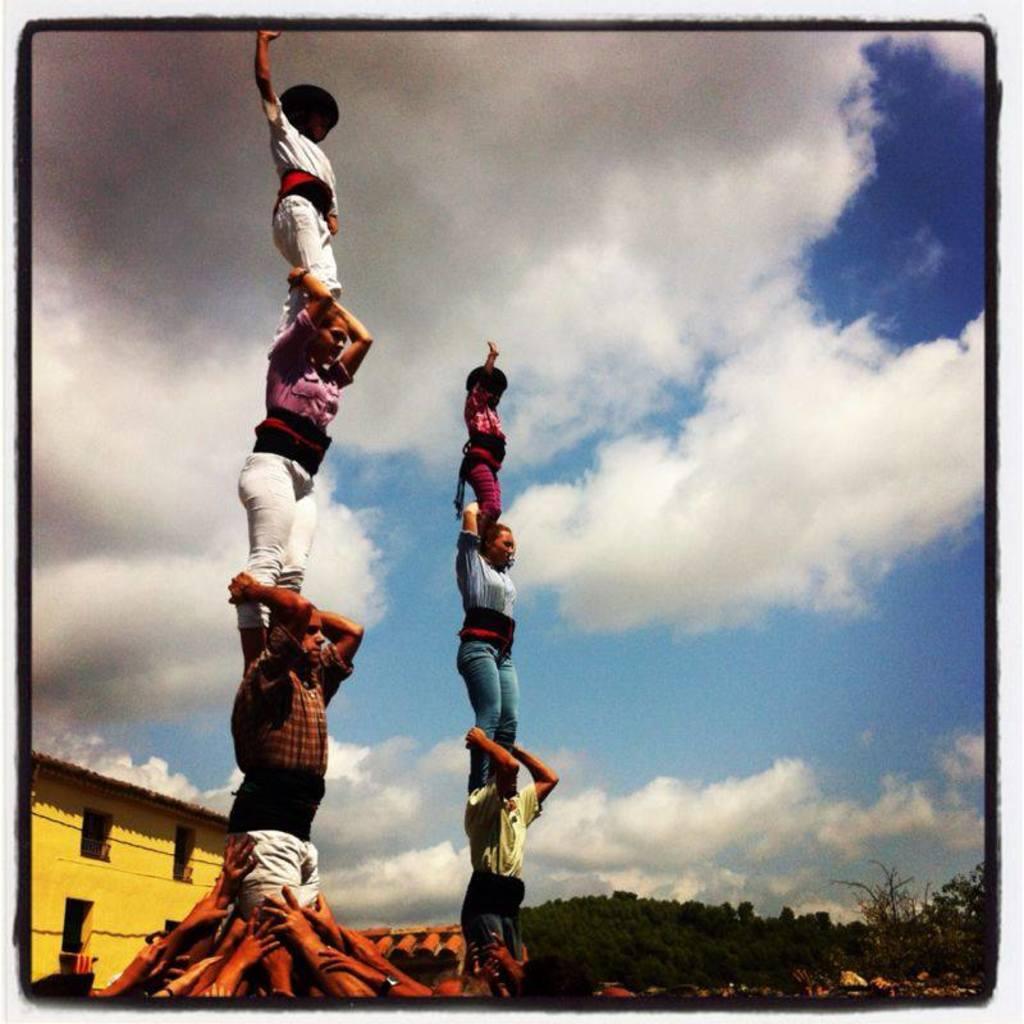Could you give a brief overview of what you see in this image? In this image there is the sky towards the top of the image, there are clouds in the sky, there are trees towards the right of the image, there is a building towards the left of the image, there is a wire towards the left of the image, there are persons hands towards the bottom of the image, there are persons standing on another person. 